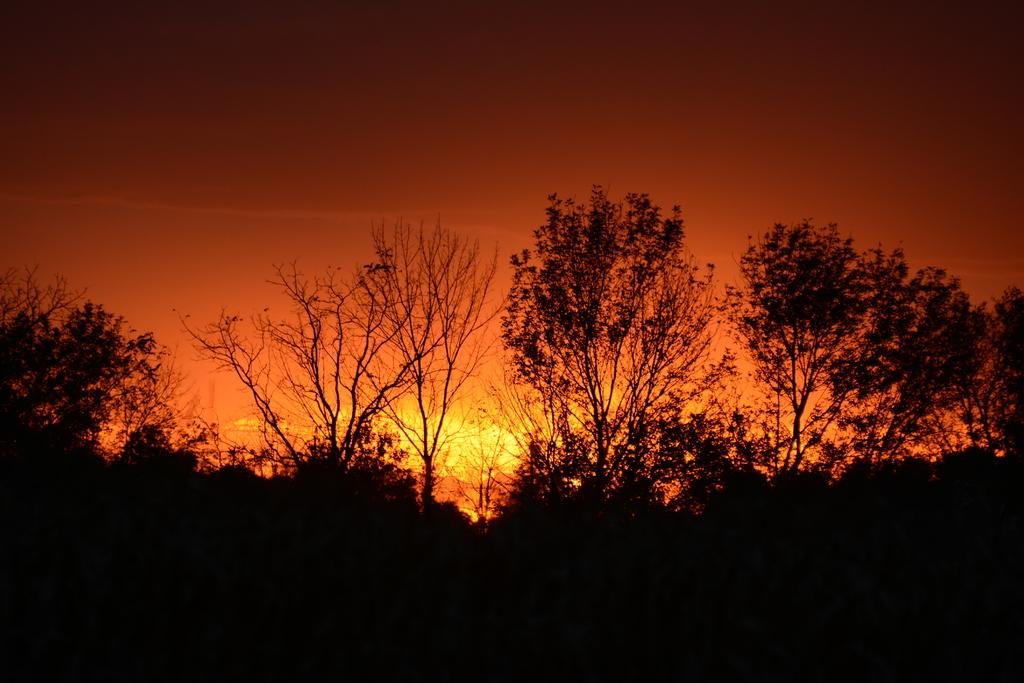What type of vegetation can be seen in the image? There are trees in the image. What part of the natural environment is visible in the image? The sky is visible in the image. Can you describe the lighting conditions in the image? Sunlight is present in the sky, indicating that it is daytime. How many snails are participating in the competition in the image? There are no snails or competitions present in the image. 